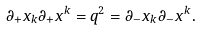<formula> <loc_0><loc_0><loc_500><loc_500>\partial _ { + } x _ { k } \partial _ { + } x ^ { k } = q ^ { 2 } = \partial _ { - } x _ { k } \partial _ { - } x ^ { k } .</formula> 